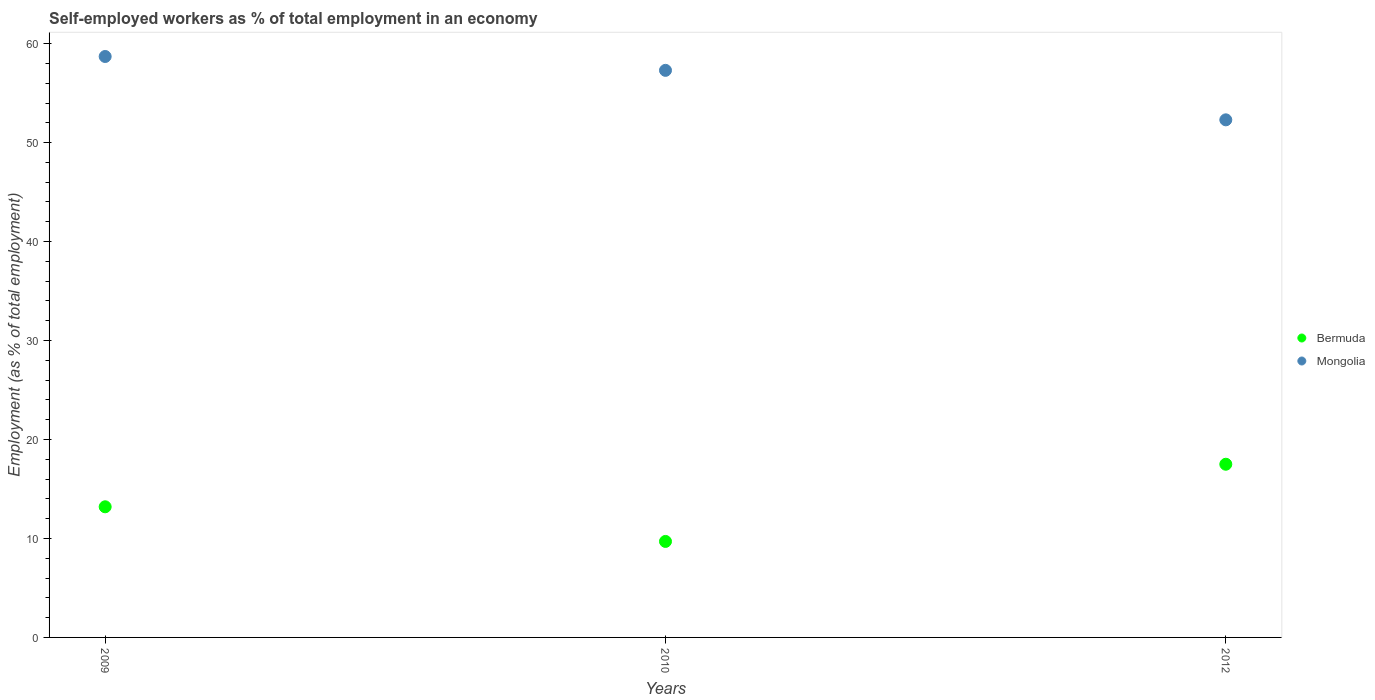Is the number of dotlines equal to the number of legend labels?
Offer a very short reply. Yes. What is the percentage of self-employed workers in Mongolia in 2009?
Give a very brief answer. 58.7. Across all years, what is the maximum percentage of self-employed workers in Mongolia?
Make the answer very short. 58.7. Across all years, what is the minimum percentage of self-employed workers in Bermuda?
Provide a short and direct response. 9.7. What is the total percentage of self-employed workers in Mongolia in the graph?
Your answer should be compact. 168.3. What is the difference between the percentage of self-employed workers in Bermuda in 2009 and that in 2012?
Provide a succinct answer. -4.3. What is the difference between the percentage of self-employed workers in Bermuda in 2012 and the percentage of self-employed workers in Mongolia in 2009?
Your response must be concise. -41.2. What is the average percentage of self-employed workers in Mongolia per year?
Your answer should be compact. 56.1. In the year 2009, what is the difference between the percentage of self-employed workers in Bermuda and percentage of self-employed workers in Mongolia?
Offer a terse response. -45.5. In how many years, is the percentage of self-employed workers in Mongolia greater than 12 %?
Keep it short and to the point. 3. What is the ratio of the percentage of self-employed workers in Mongolia in 2010 to that in 2012?
Make the answer very short. 1.1. Is the percentage of self-employed workers in Mongolia in 2010 less than that in 2012?
Provide a succinct answer. No. Is the difference between the percentage of self-employed workers in Bermuda in 2009 and 2012 greater than the difference between the percentage of self-employed workers in Mongolia in 2009 and 2012?
Provide a succinct answer. No. What is the difference between the highest and the second highest percentage of self-employed workers in Bermuda?
Offer a very short reply. 4.3. What is the difference between the highest and the lowest percentage of self-employed workers in Bermuda?
Ensure brevity in your answer.  7.8. In how many years, is the percentage of self-employed workers in Bermuda greater than the average percentage of self-employed workers in Bermuda taken over all years?
Make the answer very short. 1. Is the sum of the percentage of self-employed workers in Bermuda in 2009 and 2012 greater than the maximum percentage of self-employed workers in Mongolia across all years?
Offer a terse response. No. Does the percentage of self-employed workers in Mongolia monotonically increase over the years?
Your answer should be very brief. No. Is the percentage of self-employed workers in Mongolia strictly greater than the percentage of self-employed workers in Bermuda over the years?
Your response must be concise. Yes. How many dotlines are there?
Provide a succinct answer. 2. How many years are there in the graph?
Ensure brevity in your answer.  3. Does the graph contain any zero values?
Make the answer very short. No. Does the graph contain grids?
Ensure brevity in your answer.  No. How are the legend labels stacked?
Your response must be concise. Vertical. What is the title of the graph?
Offer a very short reply. Self-employed workers as % of total employment in an economy. Does "Virgin Islands" appear as one of the legend labels in the graph?
Your answer should be compact. No. What is the label or title of the X-axis?
Your response must be concise. Years. What is the label or title of the Y-axis?
Ensure brevity in your answer.  Employment (as % of total employment). What is the Employment (as % of total employment) of Bermuda in 2009?
Make the answer very short. 13.2. What is the Employment (as % of total employment) of Mongolia in 2009?
Keep it short and to the point. 58.7. What is the Employment (as % of total employment) of Bermuda in 2010?
Keep it short and to the point. 9.7. What is the Employment (as % of total employment) in Mongolia in 2010?
Offer a very short reply. 57.3. What is the Employment (as % of total employment) in Bermuda in 2012?
Offer a very short reply. 17.5. What is the Employment (as % of total employment) in Mongolia in 2012?
Make the answer very short. 52.3. Across all years, what is the maximum Employment (as % of total employment) of Bermuda?
Your answer should be very brief. 17.5. Across all years, what is the maximum Employment (as % of total employment) in Mongolia?
Offer a terse response. 58.7. Across all years, what is the minimum Employment (as % of total employment) in Bermuda?
Provide a short and direct response. 9.7. Across all years, what is the minimum Employment (as % of total employment) of Mongolia?
Your response must be concise. 52.3. What is the total Employment (as % of total employment) of Bermuda in the graph?
Make the answer very short. 40.4. What is the total Employment (as % of total employment) of Mongolia in the graph?
Ensure brevity in your answer.  168.3. What is the difference between the Employment (as % of total employment) of Bermuda in 2009 and that in 2010?
Make the answer very short. 3.5. What is the difference between the Employment (as % of total employment) in Bermuda in 2009 and that in 2012?
Provide a short and direct response. -4.3. What is the difference between the Employment (as % of total employment) of Mongolia in 2009 and that in 2012?
Give a very brief answer. 6.4. What is the difference between the Employment (as % of total employment) in Bermuda in 2009 and the Employment (as % of total employment) in Mongolia in 2010?
Provide a short and direct response. -44.1. What is the difference between the Employment (as % of total employment) of Bermuda in 2009 and the Employment (as % of total employment) of Mongolia in 2012?
Provide a succinct answer. -39.1. What is the difference between the Employment (as % of total employment) of Bermuda in 2010 and the Employment (as % of total employment) of Mongolia in 2012?
Your response must be concise. -42.6. What is the average Employment (as % of total employment) in Bermuda per year?
Keep it short and to the point. 13.47. What is the average Employment (as % of total employment) of Mongolia per year?
Give a very brief answer. 56.1. In the year 2009, what is the difference between the Employment (as % of total employment) of Bermuda and Employment (as % of total employment) of Mongolia?
Offer a very short reply. -45.5. In the year 2010, what is the difference between the Employment (as % of total employment) of Bermuda and Employment (as % of total employment) of Mongolia?
Provide a succinct answer. -47.6. In the year 2012, what is the difference between the Employment (as % of total employment) of Bermuda and Employment (as % of total employment) of Mongolia?
Offer a terse response. -34.8. What is the ratio of the Employment (as % of total employment) in Bermuda in 2009 to that in 2010?
Keep it short and to the point. 1.36. What is the ratio of the Employment (as % of total employment) in Mongolia in 2009 to that in 2010?
Offer a terse response. 1.02. What is the ratio of the Employment (as % of total employment) of Bermuda in 2009 to that in 2012?
Offer a very short reply. 0.75. What is the ratio of the Employment (as % of total employment) in Mongolia in 2009 to that in 2012?
Your answer should be very brief. 1.12. What is the ratio of the Employment (as % of total employment) of Bermuda in 2010 to that in 2012?
Ensure brevity in your answer.  0.55. What is the ratio of the Employment (as % of total employment) in Mongolia in 2010 to that in 2012?
Provide a short and direct response. 1.1. What is the difference between the highest and the second highest Employment (as % of total employment) in Mongolia?
Make the answer very short. 1.4. What is the difference between the highest and the lowest Employment (as % of total employment) of Bermuda?
Your answer should be compact. 7.8. What is the difference between the highest and the lowest Employment (as % of total employment) of Mongolia?
Your response must be concise. 6.4. 